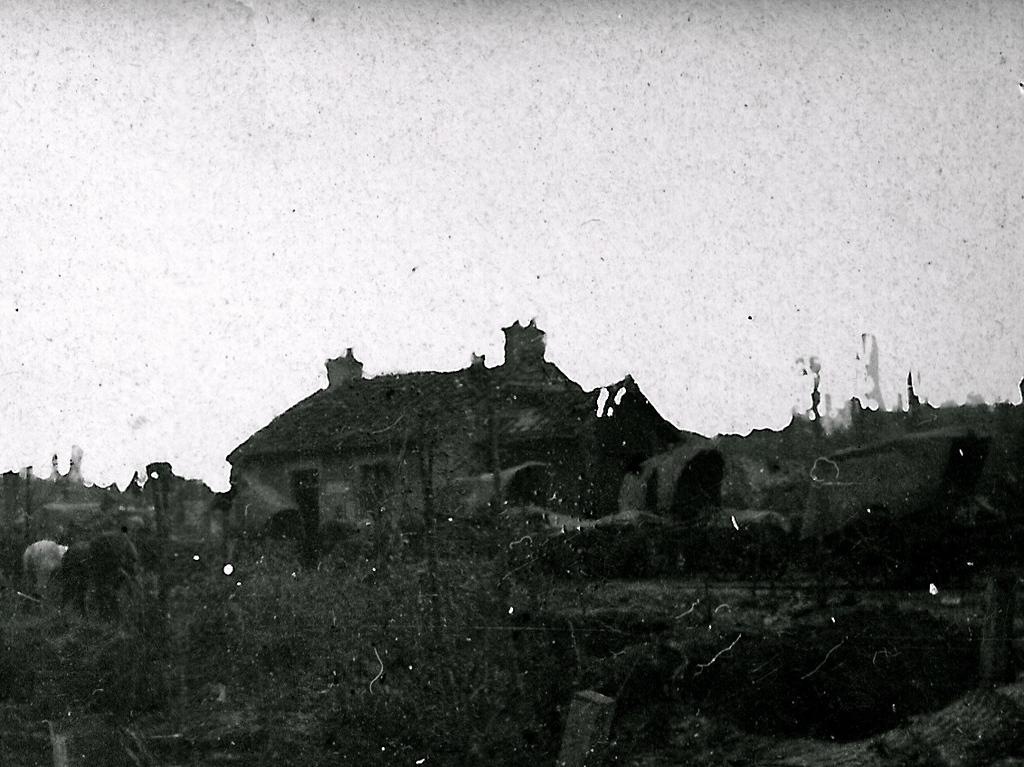What type of structure is present in the image? There is a house in the image. What other living creature can be seen in the image? There is an animal in the image. What part of the natural environment is visible in the image? The sky is visible in the image. What is the limit of the moon's gravitational pull in the image? The image does not depict the moon or its gravitational pull, so it is not possible to determine the limit of its gravitational pull. 